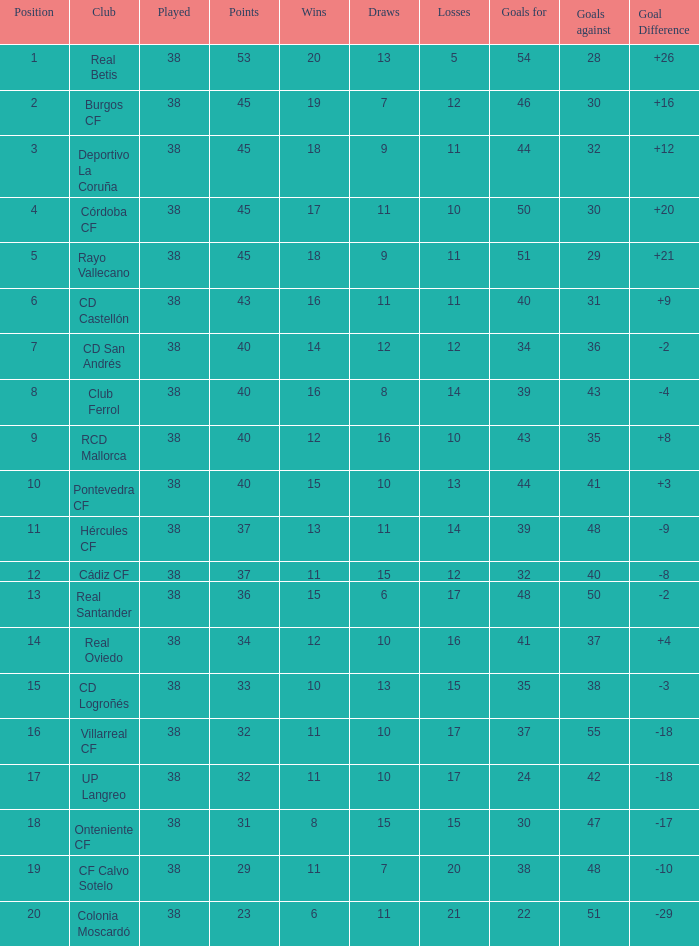What is the average Draws, when Goal Difference is greater than -3, when Goals Against is 30, and when Points is greater than 45? None. 